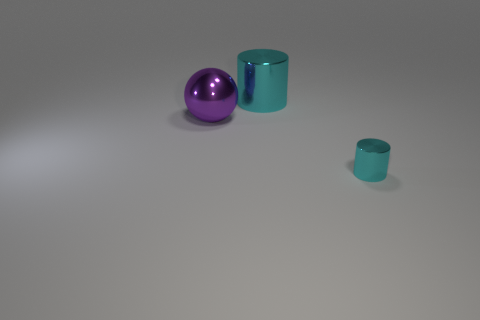What might be the function of these objects if they were real? If these objects were real, the sphere could be a decorative item like an ornament, and the cylinders could serve as containers or storage vessels. The larger cylinder might be suitable for holding bigger items, while the smaller one might be for more delicate or fewer contents. 